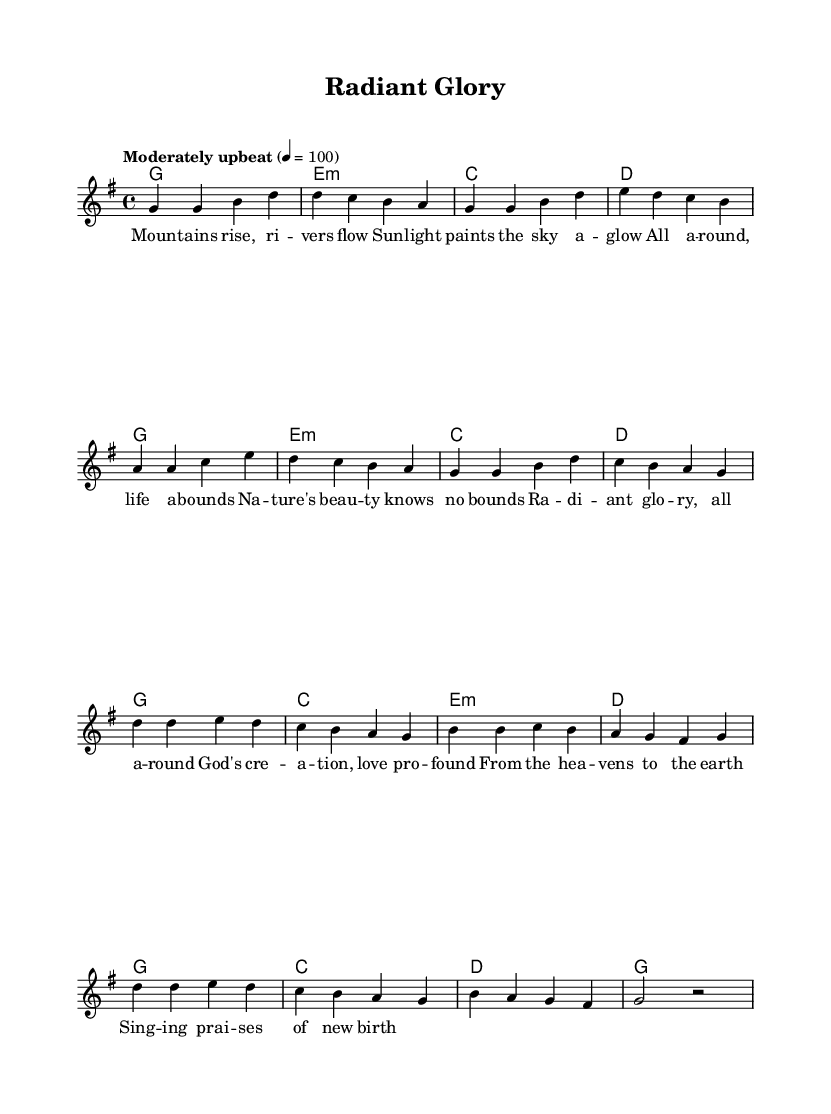What is the key signature of this music? The key signature indicates that this piece is in G major. This is identified by one sharp (F#) in the key signature at the beginning of the staff.
Answer: G major What is the time signature of this piece? The time signature is found at the beginning of the score, which shows 4/4. This means there are four beats in each measure, and the quarter note gets one beat.
Answer: 4/4 What is the tempo marking for this piece? The tempo is specified to be "Moderately upbeat" with a metronome marking of 100 beats per minute, indicating a lively and brisk pace.
Answer: Moderately upbeat How many measures are in the chorus? To find the number of measures in the chorus, you can count the measures notated between the verse's conclusion and the return to the verse structure. The chorus consists of 8 measures.
Answer: 8 What is the style of this music piece? The music is categorized as Gospel-inspired pop, shown through its uplifting lyrics about nature and God's creation, combined with harmonious chords and melodies typical of the genre.
Answer: Gospel-inspired pop Which chord follows the 'D' chord in the verse? In the chord progression of the verse, after the D chord comes the G chord as the next chord in the sequence. This indicates a return to the tonic of the key, providing resolution.
Answer: G What does the title "Radiant Glory" signify in relation to the song's theme? The title "Radiant Glory" reflects the song's emphasis on celebrating God's creation and the beauty of nature, aligning with themes suggested in the lyrics, which express awe for the world.
Answer: Celebrating God's creation 